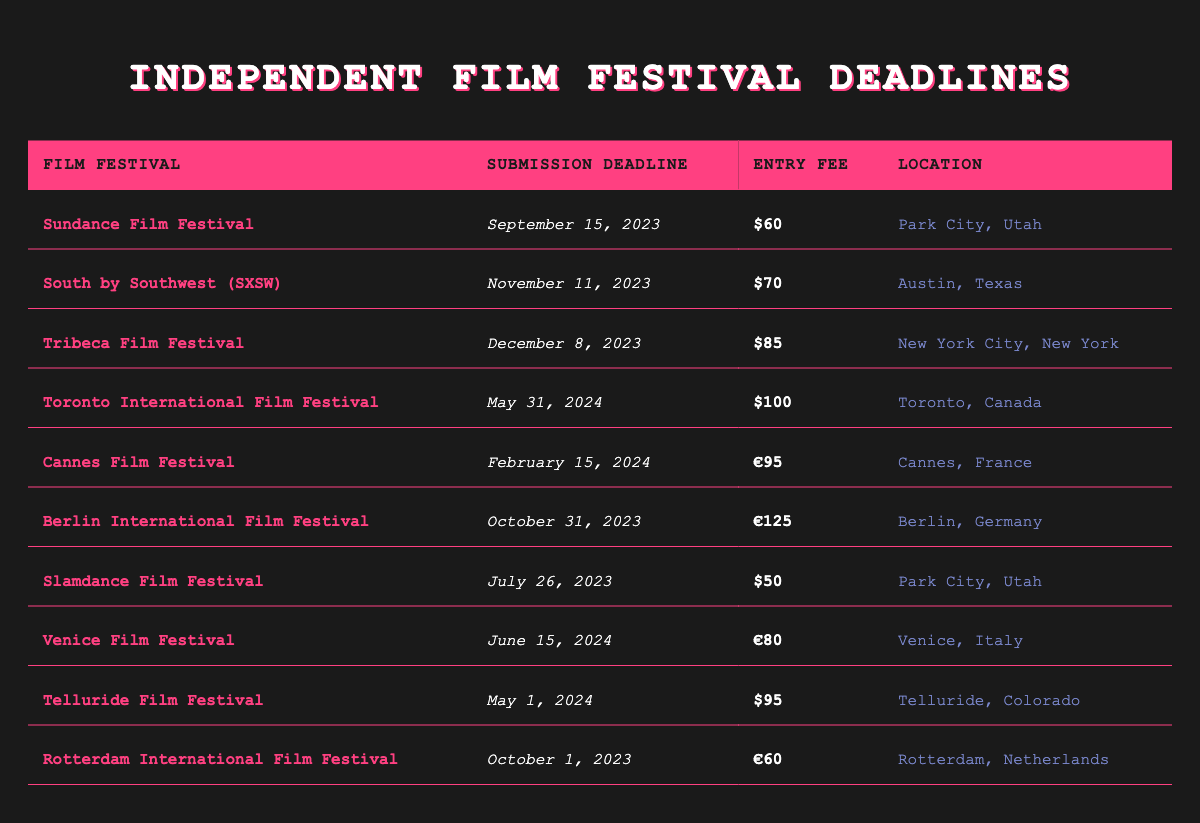What is the submission deadline for the Tribeca Film Festival? The Tribeca Film Festival deadline is listed in the table under the "Submission Deadline" column for that festival, which indicates it is December 8, 2023.
Answer: December 8, 2023 Which film festival has the highest entry fee? To find the highest entry fee, we compare the entry fees for all the festivals. The Berlin International Film Festival has an entry fee of €125, which is higher than all others listed.
Answer: €125 Is the entry fee for the Sundance Film Festival more than $50? The entry fee for the Sundance Film Festival is $60, which is indeed more than $50.
Answer: Yes How many festivals have a submission deadline in 2024? Looking at the "Submission Deadline" column, three festivals have deadlines in 2024: Toronto International Film Festival (May 31), Cannes Film Festival (February 15), Venice Film Festival (June 15), and Telluride Film Festival (May 1). Since there are four entries, the answer is 4.
Answer: 4 What is the difference in entry fees between the Tribeca Film Festival and the Slamdance Film Festival? The entry fee for the Tribeca Film Festival is $85, whereas for the Slamdance Film Festival it is $50. The difference is calculated as $85 - $50 = $35.
Answer: $35 Is the Cannes Film Festival entry fee higher than the Venice Film Festival? The Cannes Film Festival entry fee is €95, while the Venice Film Festival entry fee is €80. Since €95 is greater than €80, it confirms that Cannes has a higher fee.
Answer: Yes What is the average entry fee for festivals located in the United States? The festivals in the U.S. are Sundance ($60), SXSW ($70), Tribeca ($85), Slamdance ($50), and Telluride ($95). Adding these gives $60 + $70 + $85 + $50 + $95 = $360. Since there are 5 festivals, the average fee is $360 / 5 = $72.
Answer: $72 Which festival has an entry fee that is less than €100? By reviewing the entry fees, we look for those less than €100. Festivals like Slamdance ($50), Sundance ($60), Rotterdam (€60), and Venice (€80) meet this criterion. Thus, multiple festivals qualify.
Answer: Multiple festivals qualify Is Berlin International Film Festival located in Spain? The location for the Berlin International Film Festival is listed as Berlin, Germany. It confirms that the festival is not in Spain.
Answer: No 